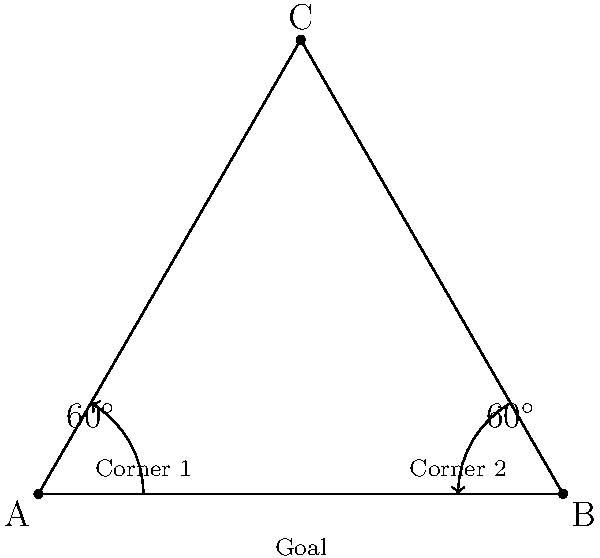At Aldo Drosina Stadium, home of Istra 1961, two corner kicks are taken from opposite corners of the pitch. If both kicks form a 60° angle with the goal line, what is the angle formed at the center of the goal between the two kick trajectories? Let's approach this step-by-step:

1) The diagram shows two corner kicks, each forming a 60° angle with the goal line.

2) The pitch forms an equilateral triangle with the two corner positions and the center of the goal.

3) In an equilateral triangle, all angles are equal and measure 60°.

4) The angle we're looking for is the angle at the top of this triangle (point C in the diagram).

5) In any triangle, the sum of all angles is always 180°.

6) If we know two angles in the triangle (both 60°), we can find the third:

   $$180^\circ - (60^\circ + 60^\circ) = 60^\circ$$

Therefore, the angle formed at the center of the goal between the two kick trajectories is 60°.
Answer: 60° 